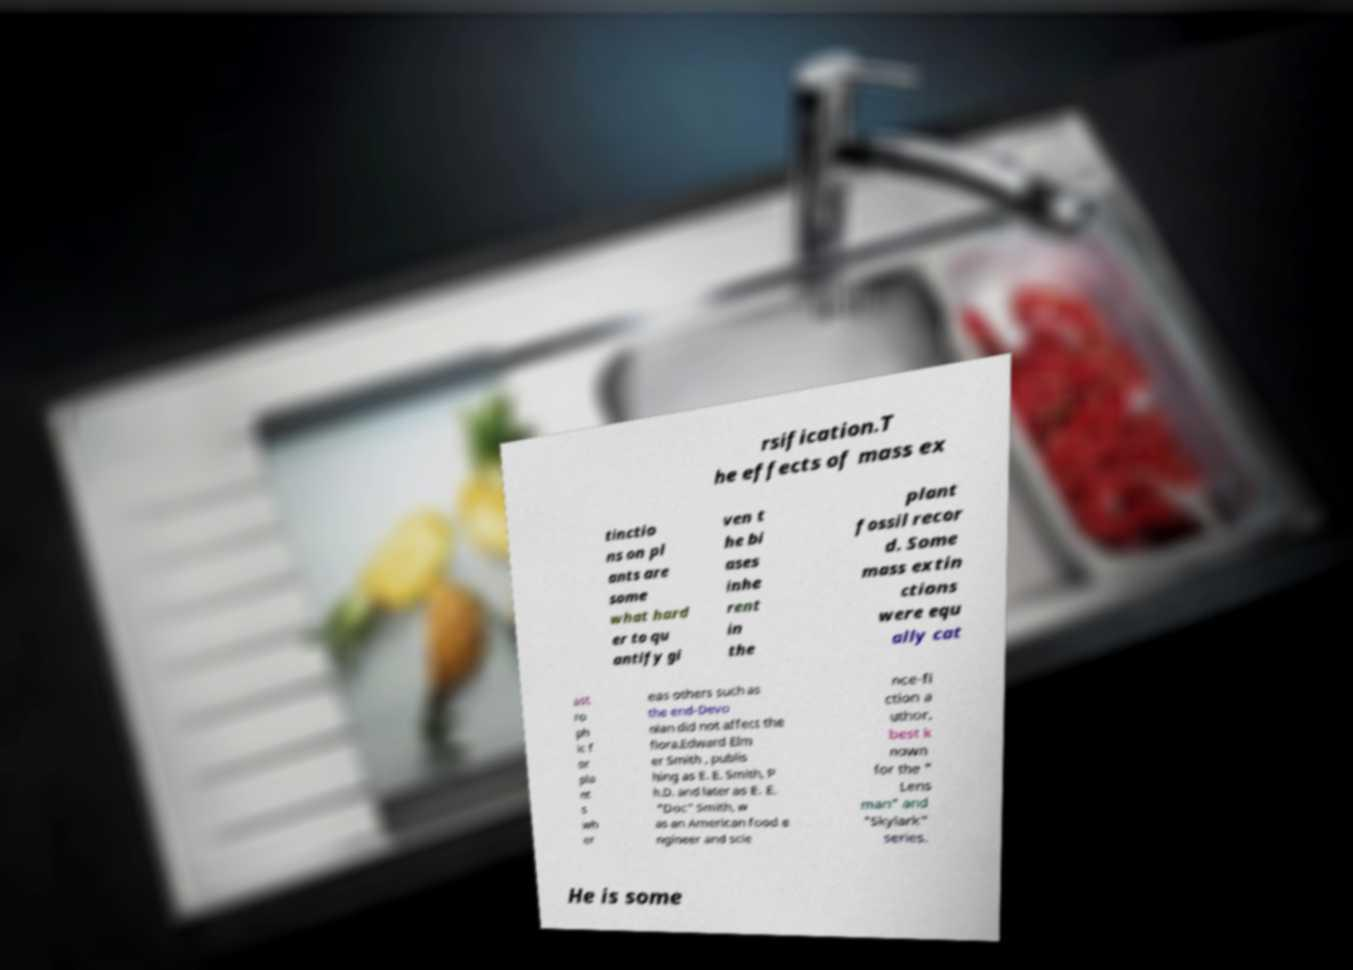Can you read and provide the text displayed in the image?This photo seems to have some interesting text. Can you extract and type it out for me? rsification.T he effects of mass ex tinctio ns on pl ants are some what hard er to qu antify gi ven t he bi ases inhe rent in the plant fossil recor d. Some mass extin ctions were equ ally cat ast ro ph ic f or pla nt s wh er eas others such as the end-Devo nian did not affect the flora.Edward Elm er Smith , publis hing as E. E. Smith, P h.D. and later as E. E. "Doc" Smith, w as an American food e ngineer and scie nce-fi ction a uthor, best k nown for the " Lens man" and "Skylark" series. He is some 